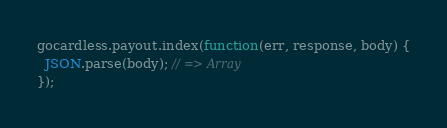Convert code to text. <code><loc_0><loc_0><loc_500><loc_500><_JavaScript_>gocardless.payout.index(function(err, response, body) {
  JSON.parse(body); // => Array
});</code> 